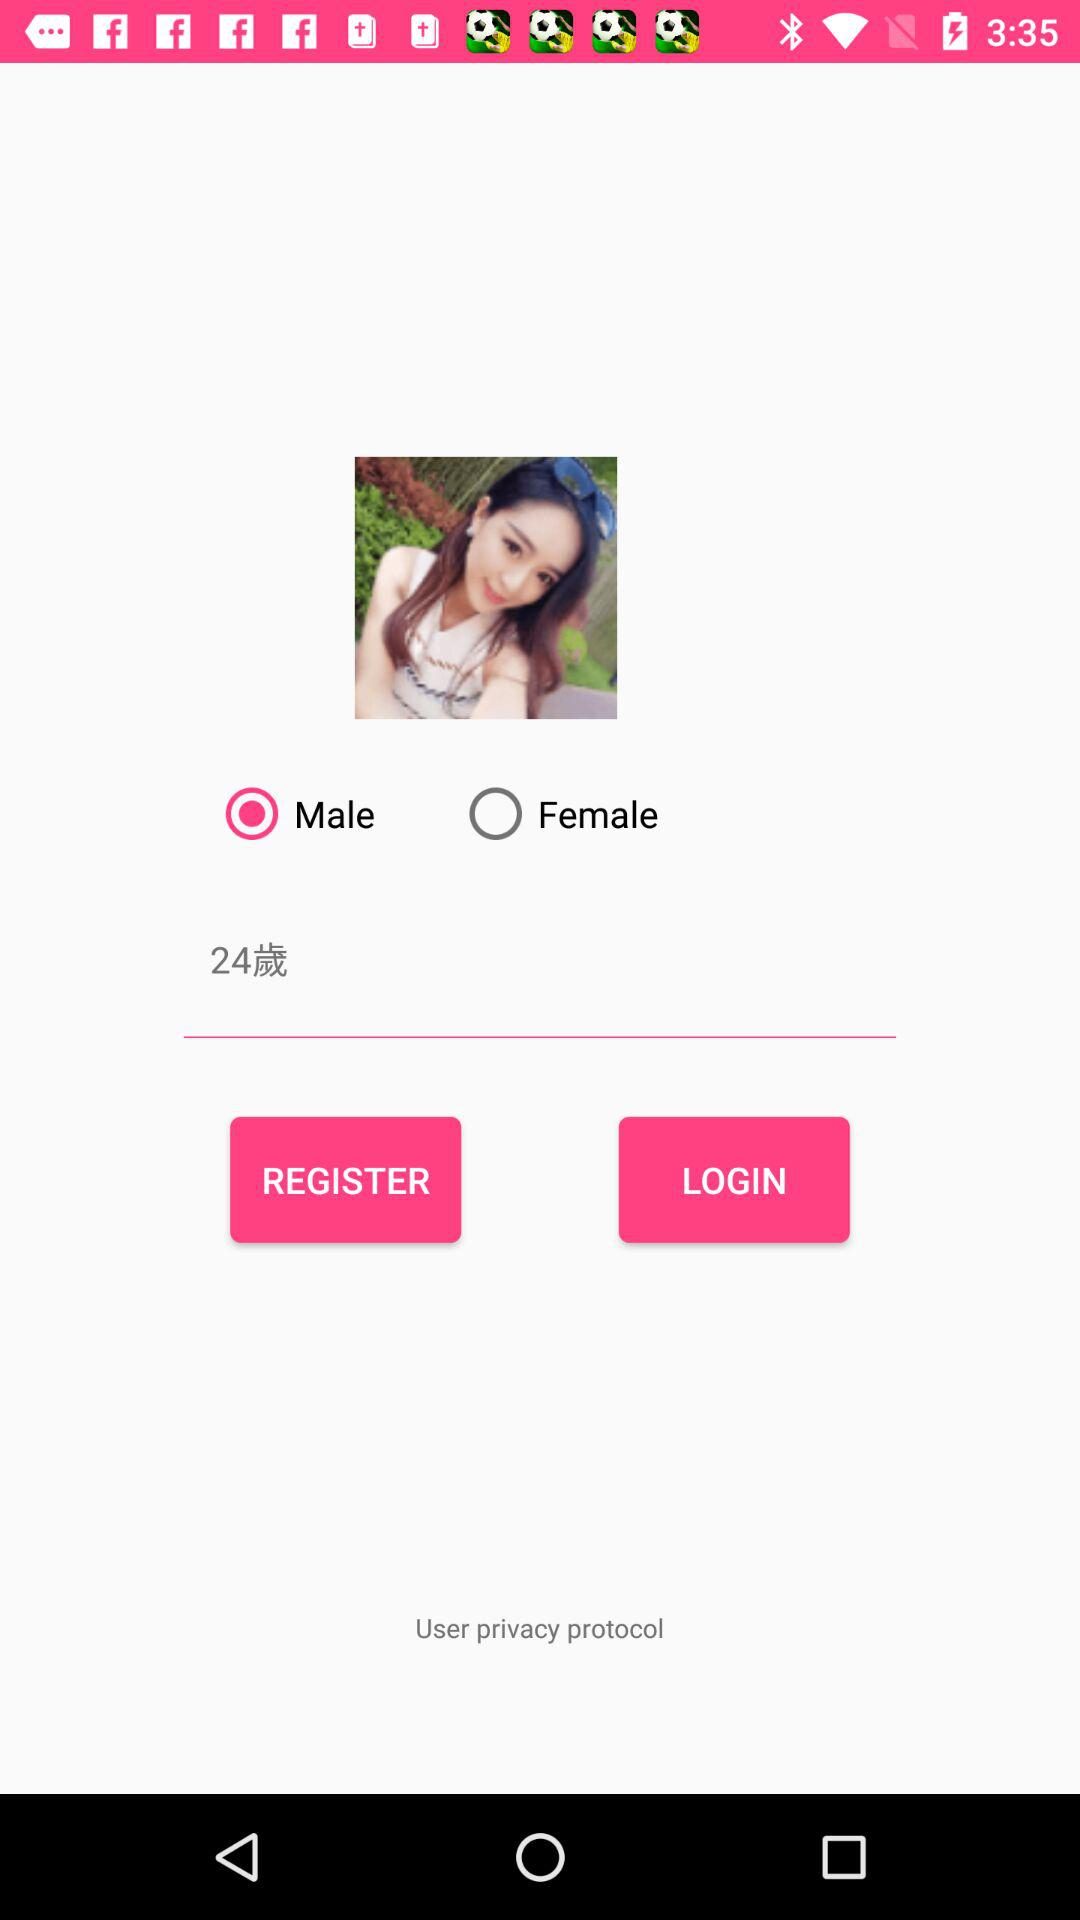What is the age? The age is 24. 